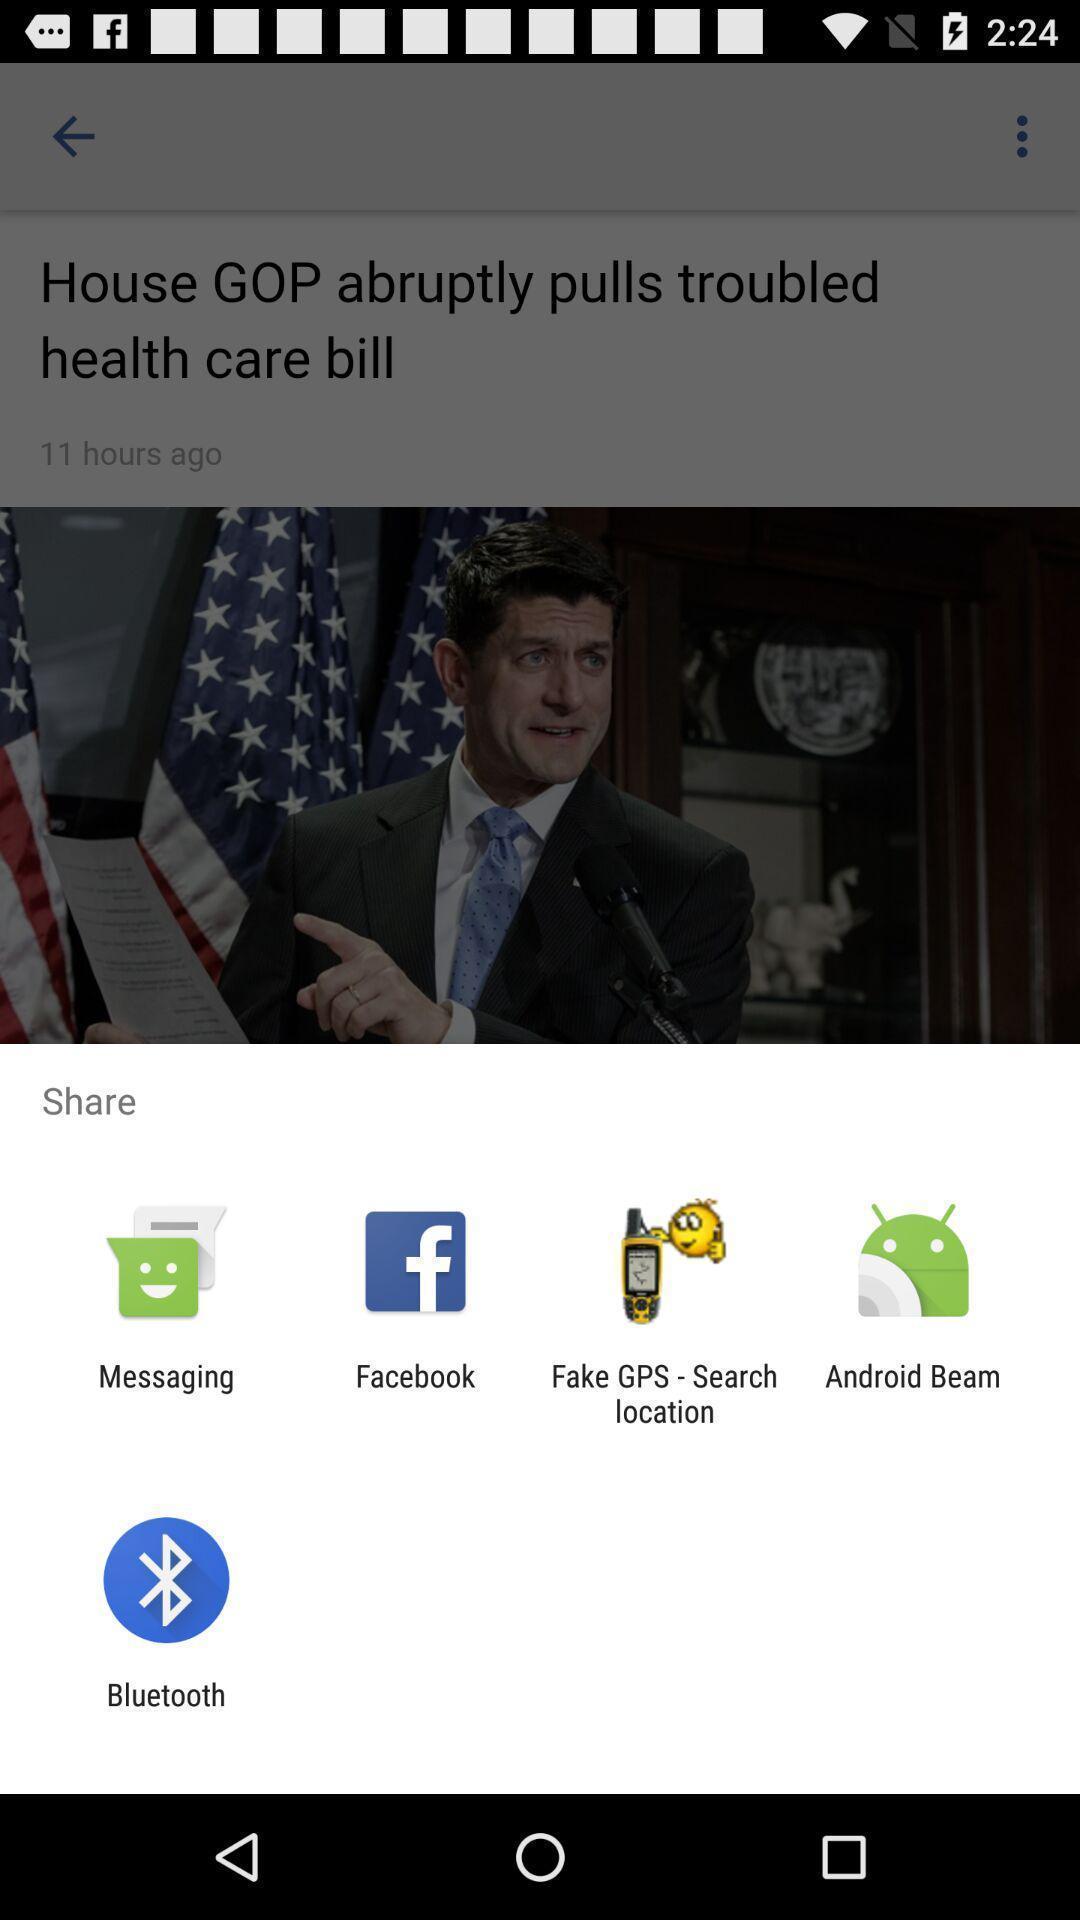Provide a textual representation of this image. Popup to share for the news app. 